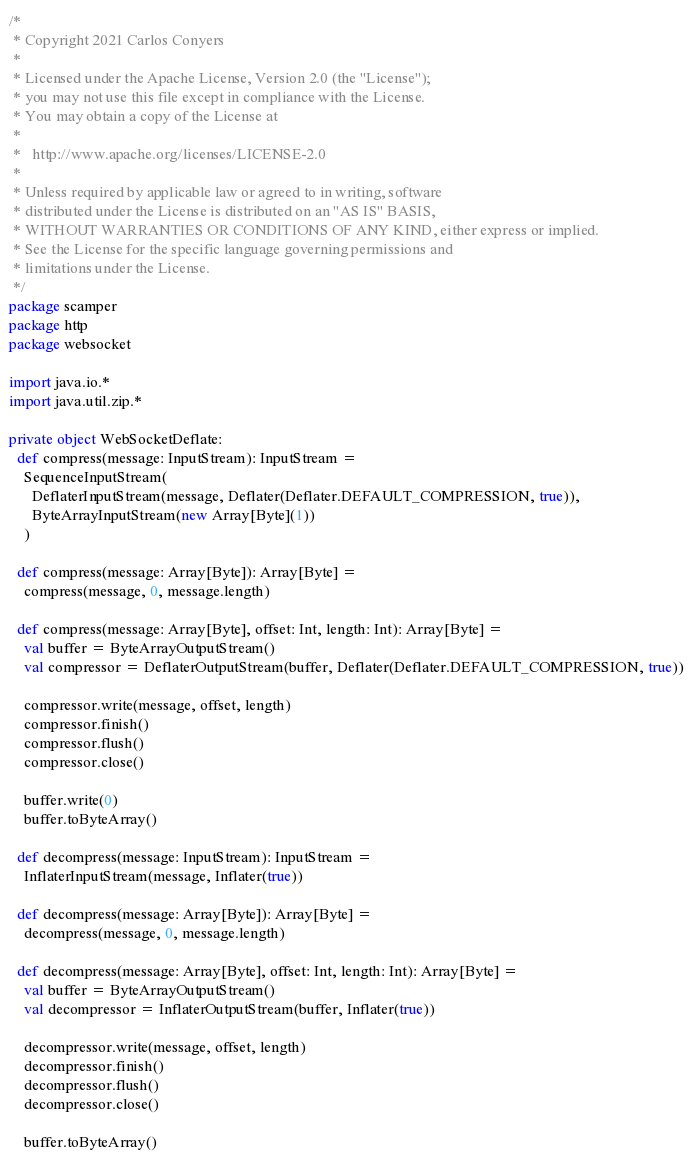Convert code to text. <code><loc_0><loc_0><loc_500><loc_500><_Scala_>/*
 * Copyright 2021 Carlos Conyers
 *
 * Licensed under the Apache License, Version 2.0 (the "License");
 * you may not use this file except in compliance with the License.
 * You may obtain a copy of the License at
 *
 *   http://www.apache.org/licenses/LICENSE-2.0
 *
 * Unless required by applicable law or agreed to in writing, software
 * distributed under the License is distributed on an "AS IS" BASIS,
 * WITHOUT WARRANTIES OR CONDITIONS OF ANY KIND, either express or implied.
 * See the License for the specific language governing permissions and
 * limitations under the License.
 */
package scamper
package http
package websocket

import java.io.*
import java.util.zip.*

private object WebSocketDeflate:
  def compress(message: InputStream): InputStream =
    SequenceInputStream(
      DeflaterInputStream(message, Deflater(Deflater.DEFAULT_COMPRESSION, true)),
      ByteArrayInputStream(new Array[Byte](1))
    )

  def compress(message: Array[Byte]): Array[Byte] =
    compress(message, 0, message.length)

  def compress(message: Array[Byte], offset: Int, length: Int): Array[Byte] =
    val buffer = ByteArrayOutputStream()
    val compressor = DeflaterOutputStream(buffer, Deflater(Deflater.DEFAULT_COMPRESSION, true))

    compressor.write(message, offset, length)
    compressor.finish()
    compressor.flush()
    compressor.close()

    buffer.write(0)
    buffer.toByteArray()

  def decompress(message: InputStream): InputStream =
    InflaterInputStream(message, Inflater(true))

  def decompress(message: Array[Byte]): Array[Byte] =
    decompress(message, 0, message.length)

  def decompress(message: Array[Byte], offset: Int, length: Int): Array[Byte] =
    val buffer = ByteArrayOutputStream()
    val decompressor = InflaterOutputStream(buffer, Inflater(true))

    decompressor.write(message, offset, length)
    decompressor.finish()
    decompressor.flush()
    decompressor.close()

    buffer.toByteArray()
</code> 